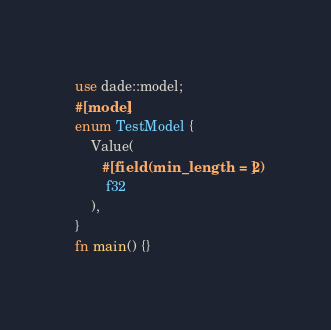Convert code to text. <code><loc_0><loc_0><loc_500><loc_500><_Rust_>use dade::model;
#[model]
enum TestModel {
    Value(
       #[field(min_length = 2)]
        f32
    ),
}
fn main() {}
</code> 